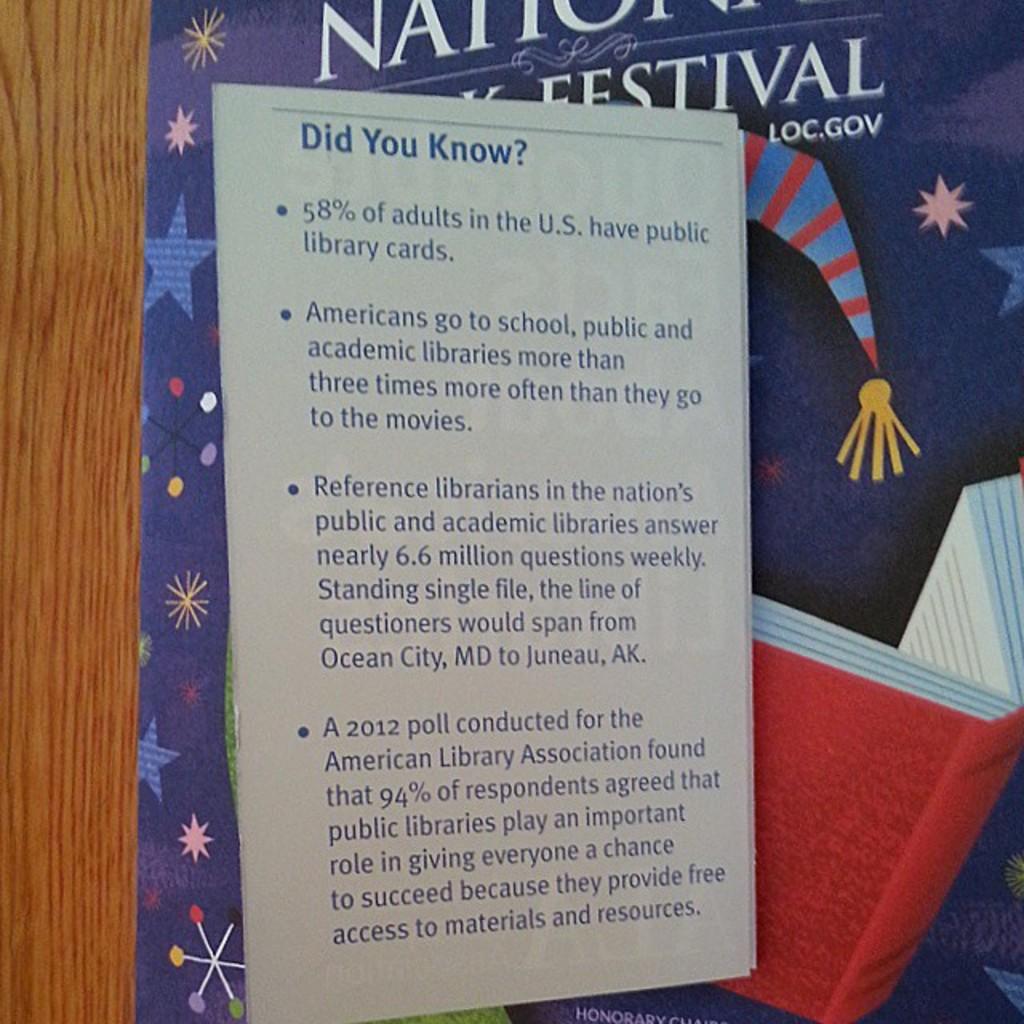What is the last word written at the end of this flyer?
Give a very brief answer. Resources. How many adults in the u.s. have a library crad?
Keep it short and to the point. 58%. 